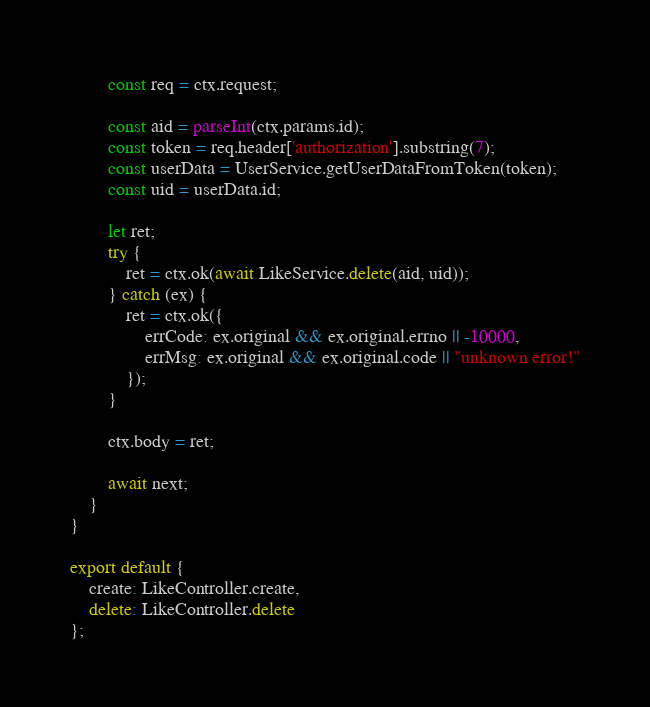Convert code to text. <code><loc_0><loc_0><loc_500><loc_500><_JavaScript_>        const req = ctx.request;

        const aid = parseInt(ctx.params.id);
        const token = req.header['authorization'].substring(7);
        const userData = UserService.getUserDataFromToken(token);
        const uid = userData.id;
        
        let ret;
        try {
            ret = ctx.ok(await LikeService.delete(aid, uid));
        } catch (ex) {
            ret = ctx.ok({
                errCode: ex.original && ex.original.errno || -10000,
                errMsg: ex.original && ex.original.code || "unknown error!"
            });
        }

        ctx.body = ret;

        await next;
    }
}

export default {
    create: LikeController.create,
    delete: LikeController.delete
};</code> 